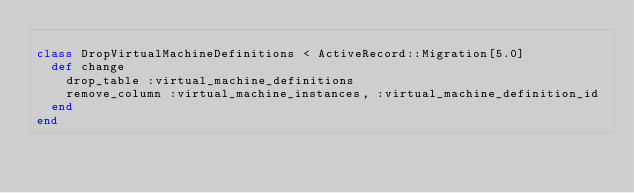Convert code to text. <code><loc_0><loc_0><loc_500><loc_500><_Ruby_>
class DropVirtualMachineDefinitions < ActiveRecord::Migration[5.0]
  def change
    drop_table :virtual_machine_definitions
    remove_column :virtual_machine_instances, :virtual_machine_definition_id
  end
end
</code> 